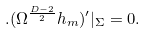<formula> <loc_0><loc_0><loc_500><loc_500>. ( \Omega ^ { \frac { D - 2 } { 2 } } h _ { m } ) ^ { \prime } | _ { \Sigma } = 0 .</formula> 